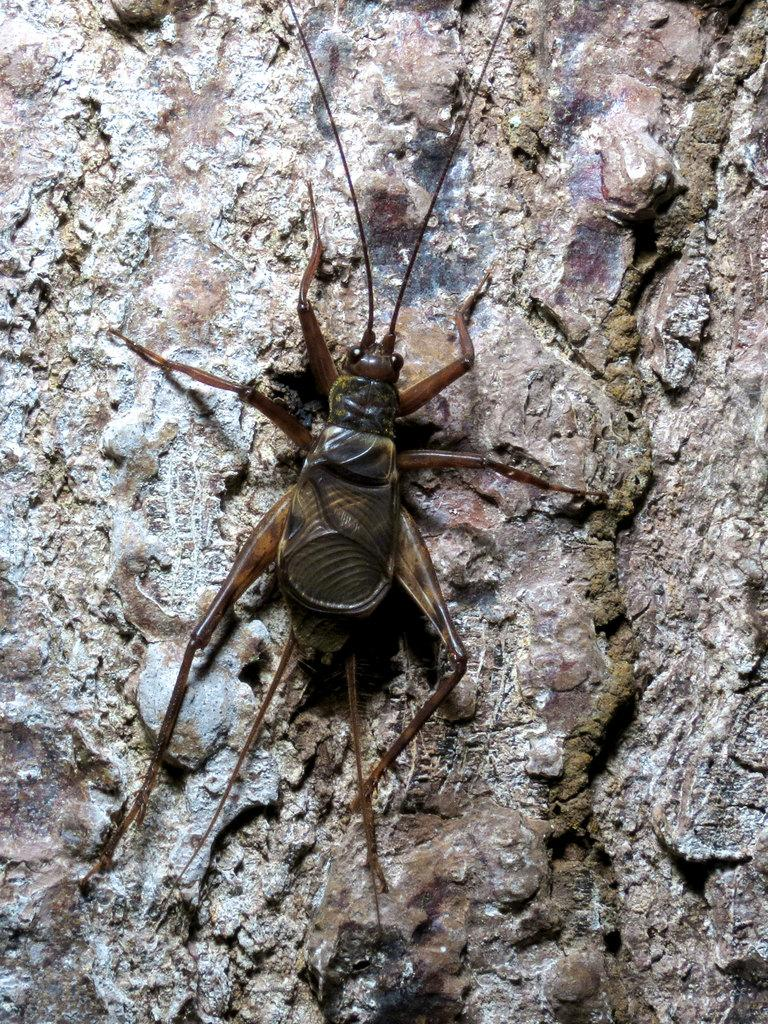What type of creature can be seen in the image? There is an insect in the image. What is the insect resting on in the image? The insect is on a solid surface. What type of lock is visible on the insect in the image? There is no lock present on the insect in the image. How does the low temperature affect the insect in the image? The provided facts do not mention the temperature, so we cannot determine how it affects the insect. 